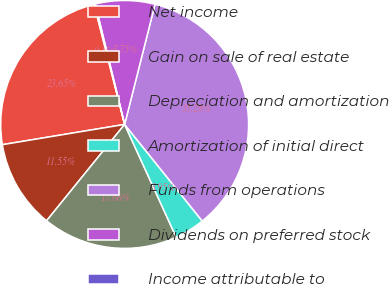Convert chart. <chart><loc_0><loc_0><loc_500><loc_500><pie_chart><fcel>Net income<fcel>Gain on sale of real estate<fcel>Depreciation and amortization<fcel>Amortization of initial direct<fcel>Funds from operations<fcel>Dividends on preferred stock<fcel>Income attributable to<nl><fcel>23.65%<fcel>11.55%<fcel>17.66%<fcel>3.95%<fcel>35.28%<fcel>7.75%<fcel>0.15%<nl></chart> 